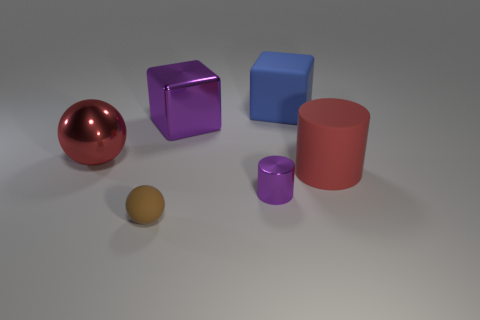Can you tell if these objects are arranged in a particular pattern or randomly placed? The objects appear to be placed in no specific pattern; they are randomly positioned within the frame. The arrangement gives an unstructured feel to the image, allowing the individual characteristics of each object, such as color and shape, to stand out on their own. 